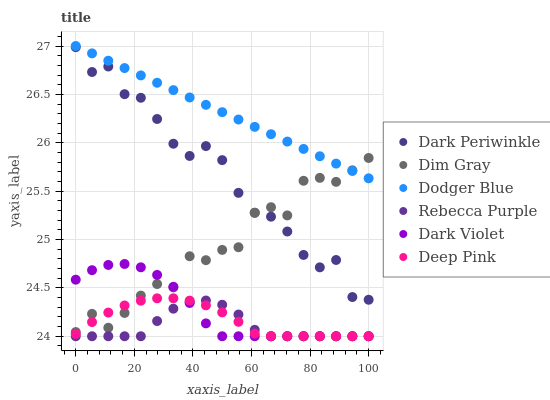Does Rebecca Purple have the minimum area under the curve?
Answer yes or no. Yes. Does Dodger Blue have the maximum area under the curve?
Answer yes or no. Yes. Does Dark Violet have the minimum area under the curve?
Answer yes or no. No. Does Dark Violet have the maximum area under the curve?
Answer yes or no. No. Is Dodger Blue the smoothest?
Answer yes or no. Yes. Is Dim Gray the roughest?
Answer yes or no. Yes. Is Dark Violet the smoothest?
Answer yes or no. No. Is Dark Violet the roughest?
Answer yes or no. No. Does Deep Pink have the lowest value?
Answer yes or no. Yes. Does Dim Gray have the lowest value?
Answer yes or no. No. Does Dodger Blue have the highest value?
Answer yes or no. Yes. Does Dark Violet have the highest value?
Answer yes or no. No. Is Rebecca Purple less than Dodger Blue?
Answer yes or no. Yes. Is Dark Periwinkle greater than Rebecca Purple?
Answer yes or no. Yes. Does Dark Violet intersect Deep Pink?
Answer yes or no. Yes. Is Dark Violet less than Deep Pink?
Answer yes or no. No. Is Dark Violet greater than Deep Pink?
Answer yes or no. No. Does Rebecca Purple intersect Dodger Blue?
Answer yes or no. No. 